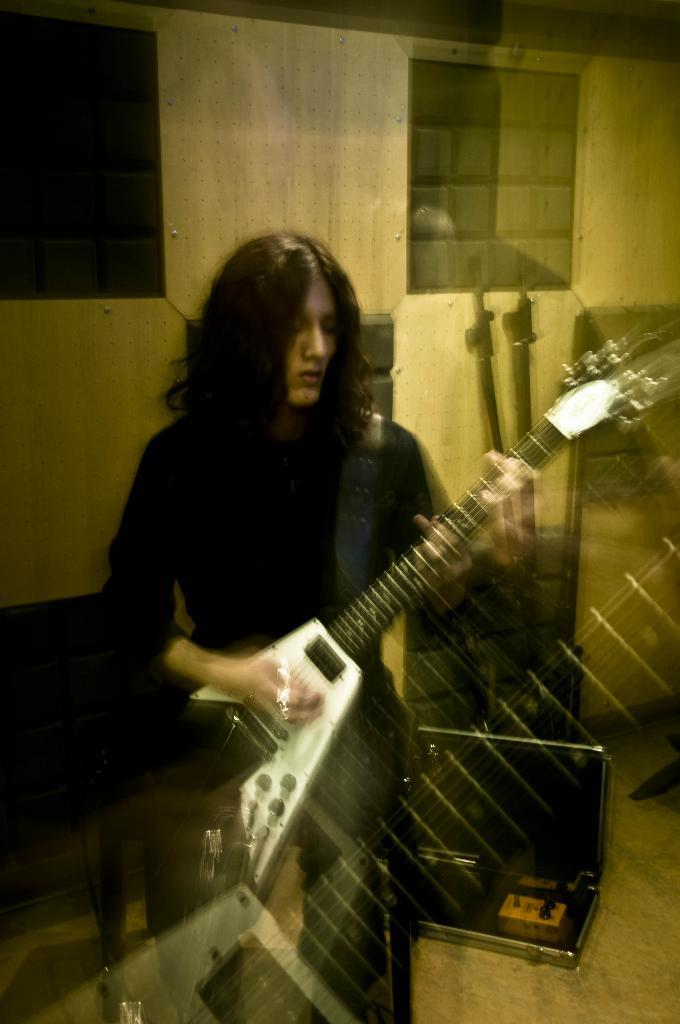What is the person in the image holding? The person is holding a guitar in the image. What is the person doing with the guitar? The person is playing the guitar. What can be seen in the background of the image? There is a wall in the background of the image. What is present on the floor in the image? There are items on the floor in the image. How would you describe the quality of the image? The image is blurred. What type of brick is the governor using to build a wall in the image? There is no governor or brick present in the image; it features a person playing a guitar. 